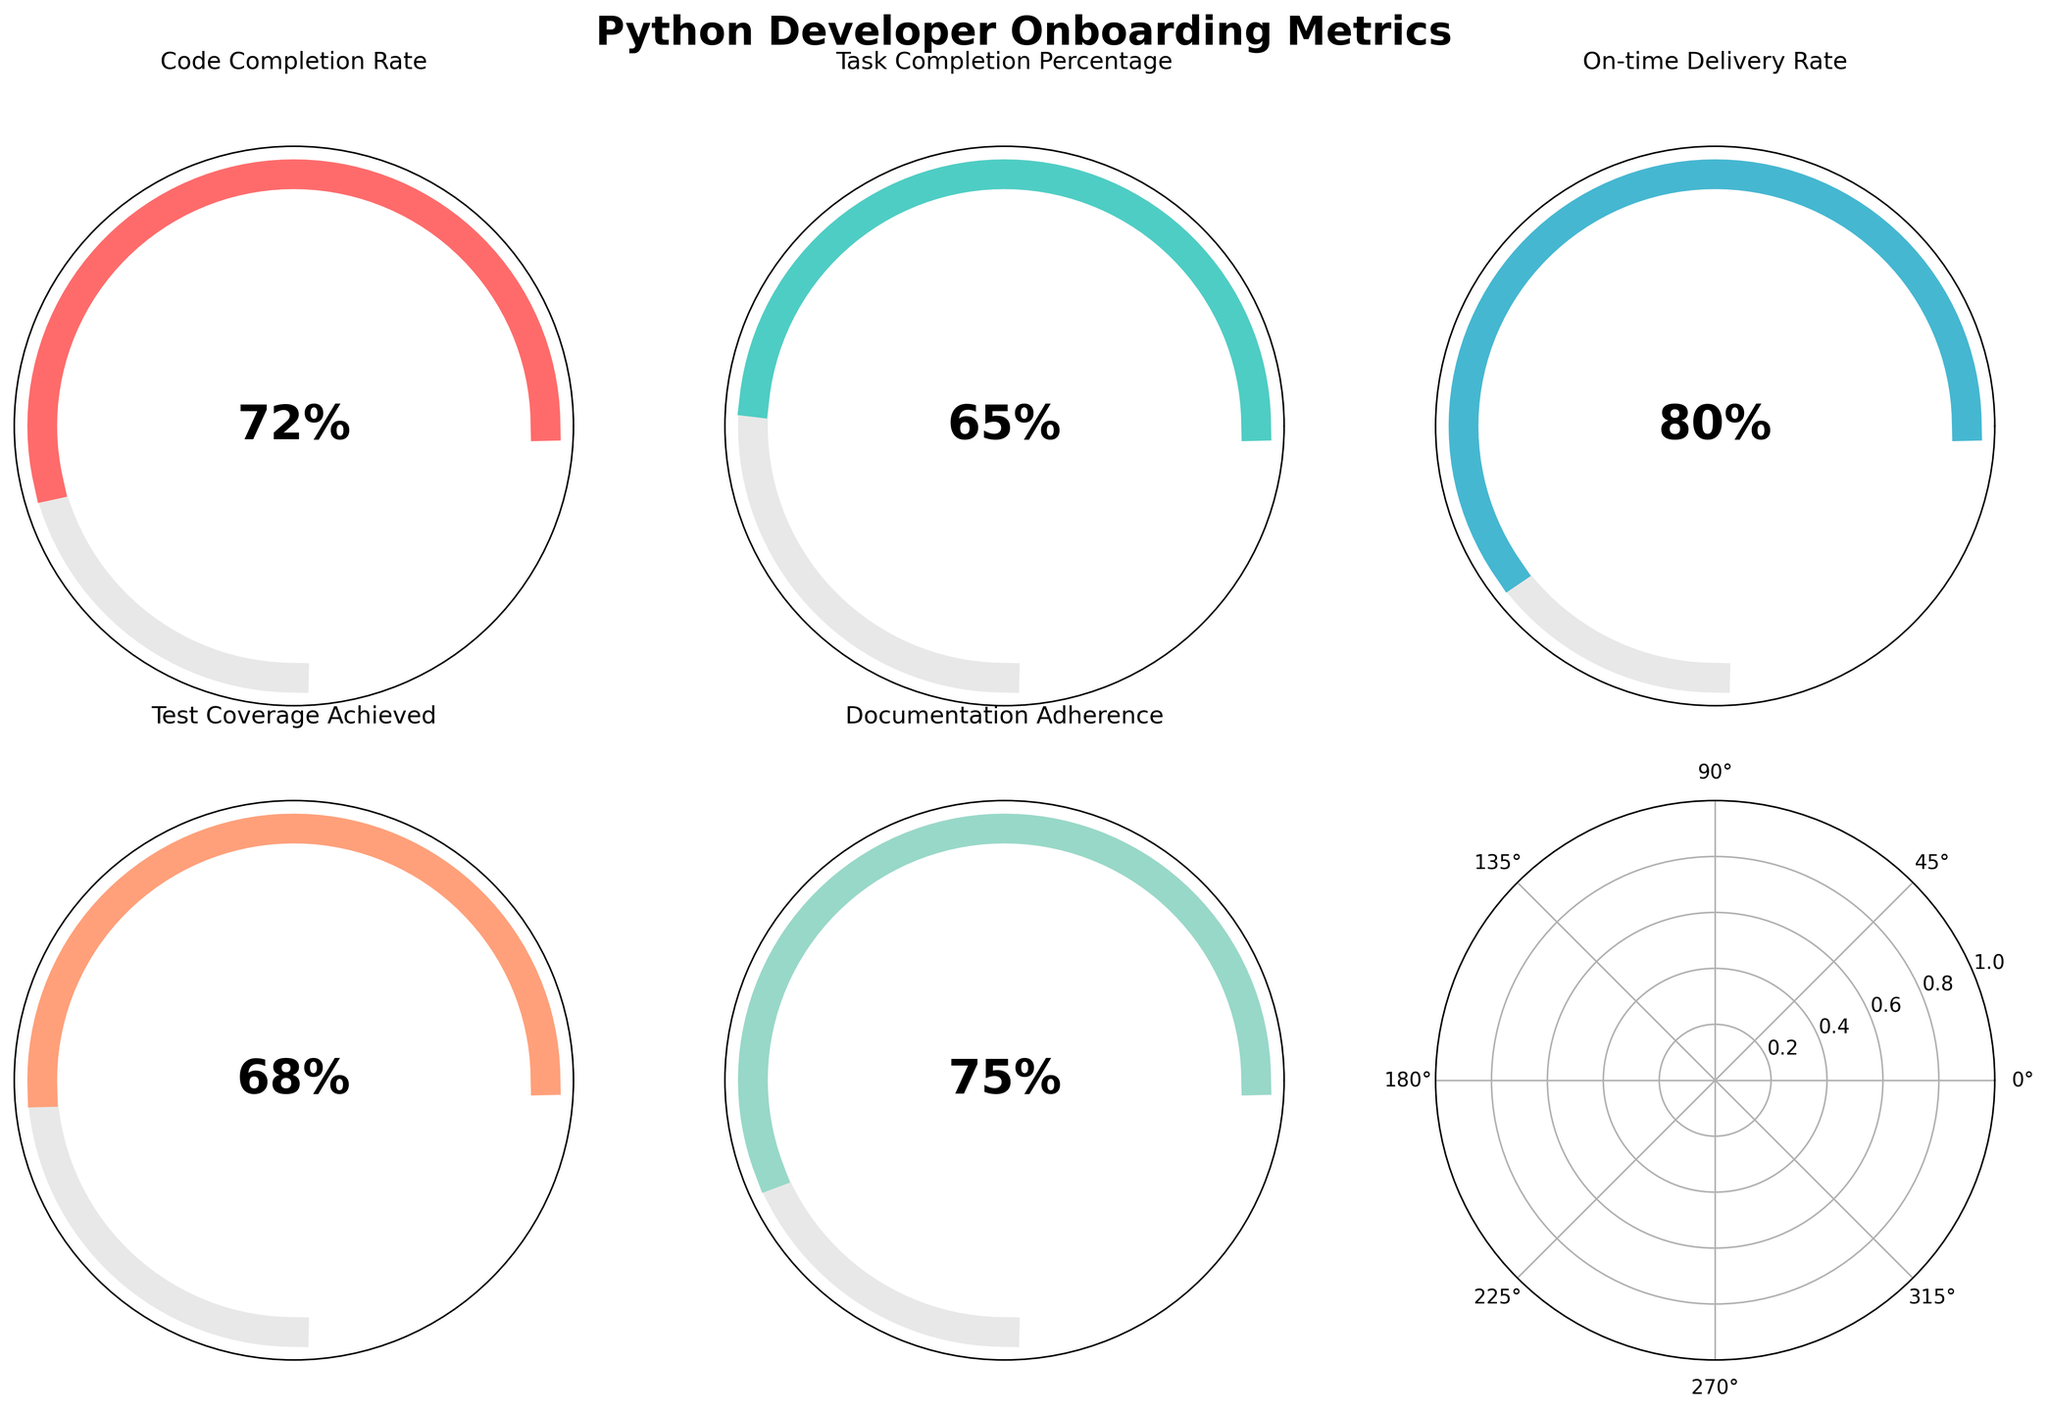What is the title of the figure? The title of the figure is prominently displayed at the top of the chart. To find it, look at the top area where the title text is usually located.
Answer: Python Developer Onboarding Metrics How many metrics are depicted in the figure? Each subplot represents one metric, and by counting the subplots, we can determine the number of metrics. We see five subplots, making it five metrics in total.
Answer: Five Which metric has the highest value? To determine this, examine each subplot and its displayed percentage value. The metric with the highest numerical value is the one with the greatest percentage.
Answer: On-time Delivery Rate Compare the Code Completion Rate with the Test Coverage Achieved. Which one is higher and by how much? First, identify the values for Code Completion Rate (72%) and Test Coverage Achieved (68%). Subtract the smaller from the larger to find the difference.
Answer: Code Completion Rate by 4% What is the average value of all the metrics? Sum the values for all metrics (72 + 65 + 80 + 68 + 75) and divide by the number of metrics (5) to get the average. (72 + 65 + 80 + 68 + 75) / 5 = 360 / 5 = 72
Answer: 72 Which metric is closest to the average value of all metrics? Calculate the average value once more (72) and compare the difference of each metric from this average: Code Completion Rate (72-72=0), Task Completion Percentage (72-65=7), On-time Delivery Rate (80-72=8), Test Coverage Achieved (72-68=4), Documentation Adherence (75-72=3). Identify the smallest absolute difference.
Answer: Code Completion Rate Are there any metrics below 70%? If so, which ones? Identify each metric and note their values. Any metric with a value below 70% meets the criterion. Specifically, Task Completion Percentage (65%) and Test Coverage Achieved (68%) are below 70%.
Answer: Task Completion Percentage, Test Coverage Achieved Which metric shows adherence to documentation? Look at the text labels on the chart to identify the one that mentions "Documentation".
Answer: Documentation Adherence Based on the visuals, which metric uses the color light green? Examine the colors used in each subplot and correspond with the specific metrics based on the visualization. The light green color corresponds to the subplot for "Documentation Adherence".
Answer: Documentation Adherence Is the Code Completion Rate closer to its maximum possible value or minimum possible value? Locate the Code Completion Rate subplot and note the percentage (72%). Considering the range (0-100), it is closer to the maximum possible value (100).
Answer: Maximum Which two metrics have the smallest and largest difference? Calculate and compare the differences between the values of all metric pairs. The smallest difference is between Code Completion Rate (72%) and Documentation Adherence (75%) with a difference of 3%, while the largest difference is between Task Completion Percentage (65%) and On-time Delivery Rate (80%) with a difference of 15%.
Answer: Code Completion Rate and Documentation Adherence, Task Completion Percentage and On-time Delivery Rate 